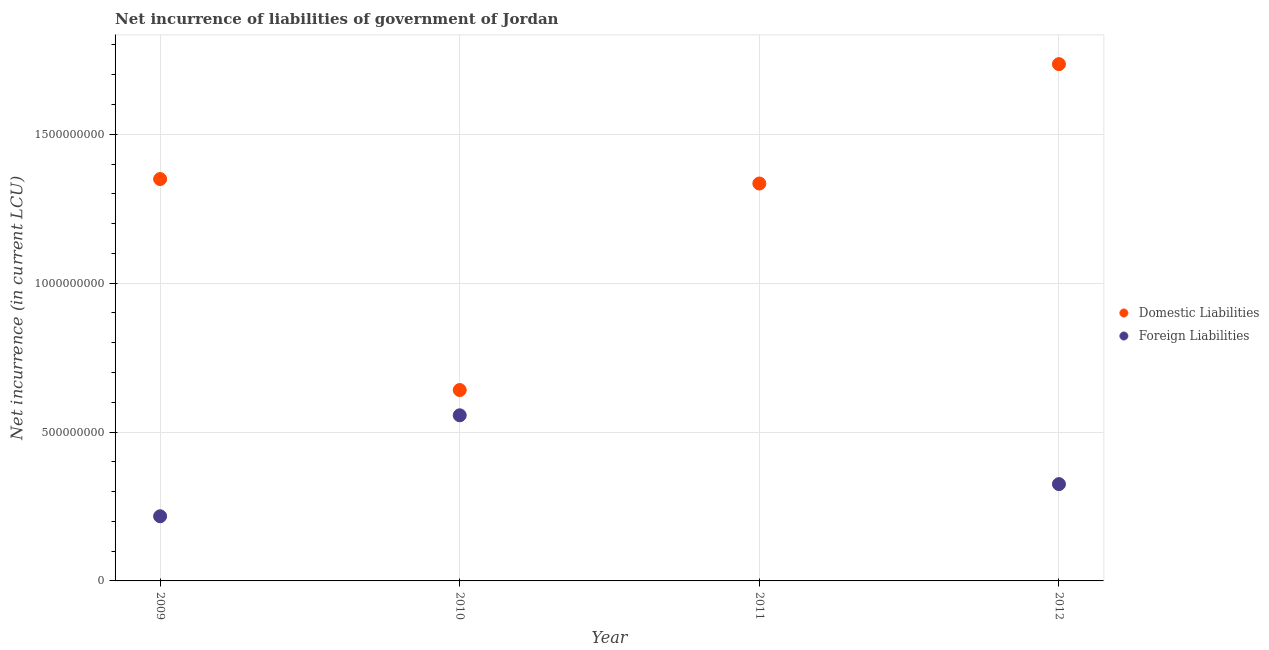How many different coloured dotlines are there?
Make the answer very short. 2. What is the net incurrence of domestic liabilities in 2011?
Offer a very short reply. 1.33e+09. Across all years, what is the maximum net incurrence of foreign liabilities?
Your answer should be compact. 5.56e+08. In which year was the net incurrence of domestic liabilities maximum?
Keep it short and to the point. 2012. What is the total net incurrence of domestic liabilities in the graph?
Your answer should be very brief. 5.06e+09. What is the difference between the net incurrence of domestic liabilities in 2009 and that in 2010?
Provide a succinct answer. 7.09e+08. What is the difference between the net incurrence of foreign liabilities in 2010 and the net incurrence of domestic liabilities in 2012?
Provide a short and direct response. -1.18e+09. What is the average net incurrence of domestic liabilities per year?
Provide a short and direct response. 1.27e+09. In the year 2010, what is the difference between the net incurrence of domestic liabilities and net incurrence of foreign liabilities?
Provide a short and direct response. 8.48e+07. In how many years, is the net incurrence of domestic liabilities greater than 400000000 LCU?
Provide a succinct answer. 4. What is the ratio of the net incurrence of foreign liabilities in 2009 to that in 2010?
Offer a very short reply. 0.39. Is the net incurrence of foreign liabilities in 2009 less than that in 2010?
Ensure brevity in your answer.  Yes. What is the difference between the highest and the second highest net incurrence of foreign liabilities?
Provide a succinct answer. 2.31e+08. What is the difference between the highest and the lowest net incurrence of domestic liabilities?
Provide a short and direct response. 1.09e+09. In how many years, is the net incurrence of domestic liabilities greater than the average net incurrence of domestic liabilities taken over all years?
Your answer should be compact. 3. Is the sum of the net incurrence of domestic liabilities in 2010 and 2012 greater than the maximum net incurrence of foreign liabilities across all years?
Your response must be concise. Yes. Is the net incurrence of domestic liabilities strictly greater than the net incurrence of foreign liabilities over the years?
Provide a short and direct response. Yes. Is the net incurrence of foreign liabilities strictly less than the net incurrence of domestic liabilities over the years?
Give a very brief answer. Yes. Are the values on the major ticks of Y-axis written in scientific E-notation?
Offer a terse response. No. Where does the legend appear in the graph?
Make the answer very short. Center right. How are the legend labels stacked?
Your answer should be compact. Vertical. What is the title of the graph?
Offer a very short reply. Net incurrence of liabilities of government of Jordan. What is the label or title of the Y-axis?
Your answer should be very brief. Net incurrence (in current LCU). What is the Net incurrence (in current LCU) of Domestic Liabilities in 2009?
Give a very brief answer. 1.35e+09. What is the Net incurrence (in current LCU) in Foreign Liabilities in 2009?
Give a very brief answer. 2.17e+08. What is the Net incurrence (in current LCU) of Domestic Liabilities in 2010?
Give a very brief answer. 6.41e+08. What is the Net incurrence (in current LCU) of Foreign Liabilities in 2010?
Your answer should be very brief. 5.56e+08. What is the Net incurrence (in current LCU) in Domestic Liabilities in 2011?
Offer a very short reply. 1.33e+09. What is the Net incurrence (in current LCU) of Domestic Liabilities in 2012?
Your answer should be compact. 1.74e+09. What is the Net incurrence (in current LCU) in Foreign Liabilities in 2012?
Your response must be concise. 3.25e+08. Across all years, what is the maximum Net incurrence (in current LCU) of Domestic Liabilities?
Ensure brevity in your answer.  1.74e+09. Across all years, what is the maximum Net incurrence (in current LCU) of Foreign Liabilities?
Your answer should be very brief. 5.56e+08. Across all years, what is the minimum Net incurrence (in current LCU) in Domestic Liabilities?
Provide a short and direct response. 6.41e+08. What is the total Net incurrence (in current LCU) in Domestic Liabilities in the graph?
Your answer should be very brief. 5.06e+09. What is the total Net incurrence (in current LCU) in Foreign Liabilities in the graph?
Offer a very short reply. 1.10e+09. What is the difference between the Net incurrence (in current LCU) of Domestic Liabilities in 2009 and that in 2010?
Ensure brevity in your answer.  7.09e+08. What is the difference between the Net incurrence (in current LCU) of Foreign Liabilities in 2009 and that in 2010?
Make the answer very short. -3.39e+08. What is the difference between the Net incurrence (in current LCU) of Domestic Liabilities in 2009 and that in 2011?
Give a very brief answer. 1.50e+07. What is the difference between the Net incurrence (in current LCU) in Domestic Liabilities in 2009 and that in 2012?
Offer a very short reply. -3.86e+08. What is the difference between the Net incurrence (in current LCU) of Foreign Liabilities in 2009 and that in 2012?
Offer a terse response. -1.08e+08. What is the difference between the Net incurrence (in current LCU) of Domestic Liabilities in 2010 and that in 2011?
Provide a short and direct response. -6.94e+08. What is the difference between the Net incurrence (in current LCU) in Domestic Liabilities in 2010 and that in 2012?
Make the answer very short. -1.09e+09. What is the difference between the Net incurrence (in current LCU) of Foreign Liabilities in 2010 and that in 2012?
Offer a terse response. 2.31e+08. What is the difference between the Net incurrence (in current LCU) in Domestic Liabilities in 2011 and that in 2012?
Make the answer very short. -4.01e+08. What is the difference between the Net incurrence (in current LCU) in Domestic Liabilities in 2009 and the Net incurrence (in current LCU) in Foreign Liabilities in 2010?
Keep it short and to the point. 7.93e+08. What is the difference between the Net incurrence (in current LCU) in Domestic Liabilities in 2009 and the Net incurrence (in current LCU) in Foreign Liabilities in 2012?
Provide a succinct answer. 1.02e+09. What is the difference between the Net incurrence (in current LCU) of Domestic Liabilities in 2010 and the Net incurrence (in current LCU) of Foreign Liabilities in 2012?
Your answer should be compact. 3.16e+08. What is the difference between the Net incurrence (in current LCU) of Domestic Liabilities in 2011 and the Net incurrence (in current LCU) of Foreign Liabilities in 2012?
Provide a succinct answer. 1.01e+09. What is the average Net incurrence (in current LCU) of Domestic Liabilities per year?
Your answer should be very brief. 1.27e+09. What is the average Net incurrence (in current LCU) in Foreign Liabilities per year?
Ensure brevity in your answer.  2.75e+08. In the year 2009, what is the difference between the Net incurrence (in current LCU) in Domestic Liabilities and Net incurrence (in current LCU) in Foreign Liabilities?
Make the answer very short. 1.13e+09. In the year 2010, what is the difference between the Net incurrence (in current LCU) of Domestic Liabilities and Net incurrence (in current LCU) of Foreign Liabilities?
Provide a succinct answer. 8.48e+07. In the year 2012, what is the difference between the Net incurrence (in current LCU) of Domestic Liabilities and Net incurrence (in current LCU) of Foreign Liabilities?
Offer a terse response. 1.41e+09. What is the ratio of the Net incurrence (in current LCU) of Domestic Liabilities in 2009 to that in 2010?
Provide a short and direct response. 2.11. What is the ratio of the Net incurrence (in current LCU) in Foreign Liabilities in 2009 to that in 2010?
Your answer should be compact. 0.39. What is the ratio of the Net incurrence (in current LCU) of Domestic Liabilities in 2009 to that in 2011?
Your response must be concise. 1.01. What is the ratio of the Net incurrence (in current LCU) in Domestic Liabilities in 2009 to that in 2012?
Your answer should be very brief. 0.78. What is the ratio of the Net incurrence (in current LCU) in Foreign Liabilities in 2009 to that in 2012?
Offer a terse response. 0.67. What is the ratio of the Net incurrence (in current LCU) of Domestic Liabilities in 2010 to that in 2011?
Offer a terse response. 0.48. What is the ratio of the Net incurrence (in current LCU) of Domestic Liabilities in 2010 to that in 2012?
Your answer should be very brief. 0.37. What is the ratio of the Net incurrence (in current LCU) in Foreign Liabilities in 2010 to that in 2012?
Your answer should be very brief. 1.71. What is the ratio of the Net incurrence (in current LCU) in Domestic Liabilities in 2011 to that in 2012?
Your response must be concise. 0.77. What is the difference between the highest and the second highest Net incurrence (in current LCU) of Domestic Liabilities?
Provide a short and direct response. 3.86e+08. What is the difference between the highest and the second highest Net incurrence (in current LCU) in Foreign Liabilities?
Keep it short and to the point. 2.31e+08. What is the difference between the highest and the lowest Net incurrence (in current LCU) of Domestic Liabilities?
Offer a terse response. 1.09e+09. What is the difference between the highest and the lowest Net incurrence (in current LCU) in Foreign Liabilities?
Provide a short and direct response. 5.56e+08. 